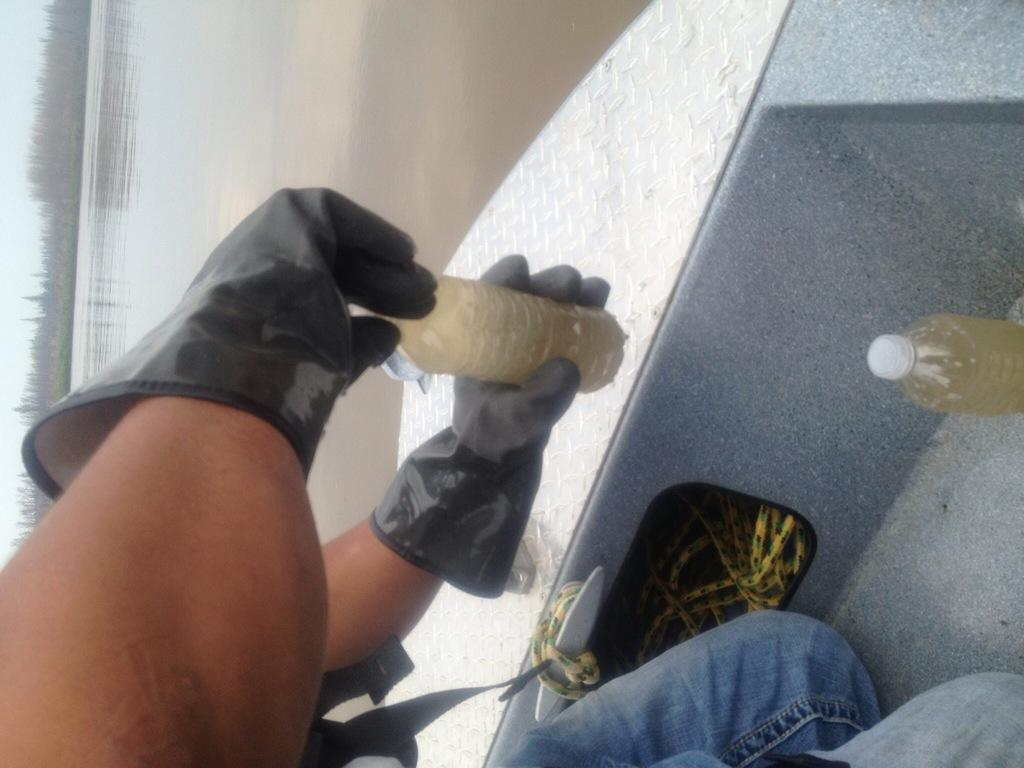What is the person in the image doing? The person is sitting inside a boat. What is the person wearing on their hands? The person is wearing black gloves. What object is the person holding in the image? The person is holding a water bottle. What can be seen in the background of the image? There are trees visible in the background, and they are located near a pond. How is the image oriented? The image is in a vertical orientation. What type of drug can be seen in the person's hand in the image? There is no drug present in the image; the person is holding a water bottle. What type of jar is visible on the person's neck in the image? There is no jar visible on the person's neck in the image. 